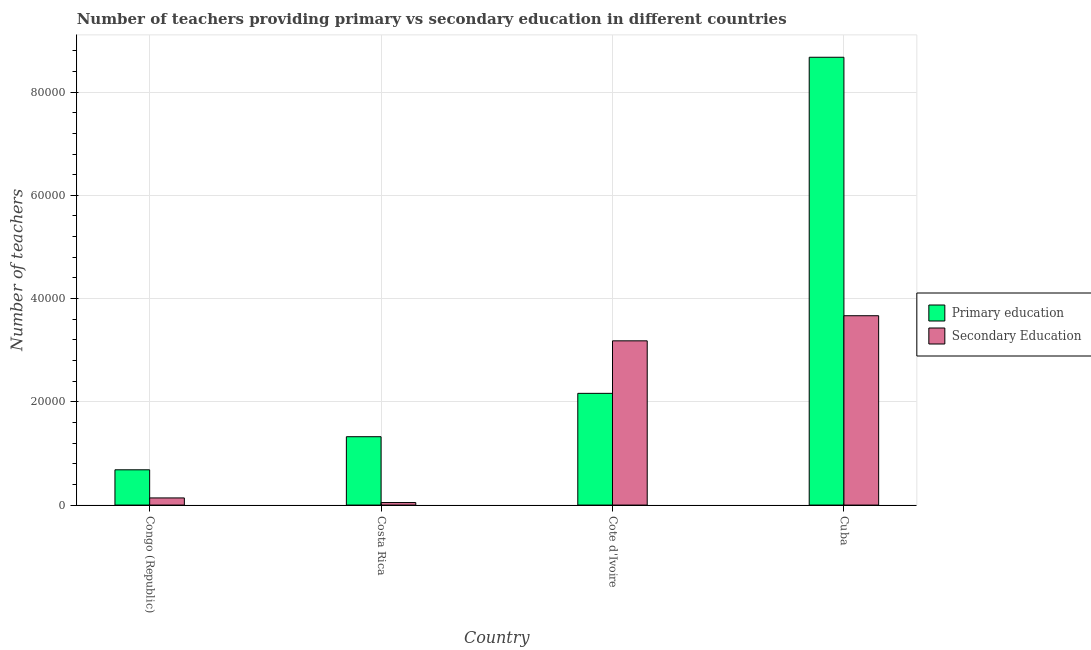How many groups of bars are there?
Ensure brevity in your answer.  4. Are the number of bars on each tick of the X-axis equal?
Provide a short and direct response. Yes. How many bars are there on the 3rd tick from the left?
Your answer should be compact. 2. What is the label of the 4th group of bars from the left?
Provide a succinct answer. Cuba. What is the number of secondary teachers in Congo (Republic)?
Your answer should be compact. 1383. Across all countries, what is the maximum number of primary teachers?
Give a very brief answer. 8.67e+04. Across all countries, what is the minimum number of secondary teachers?
Your answer should be compact. 490. In which country was the number of secondary teachers maximum?
Your answer should be compact. Cuba. In which country was the number of primary teachers minimum?
Give a very brief answer. Congo (Republic). What is the total number of secondary teachers in the graph?
Provide a succinct answer. 7.04e+04. What is the difference between the number of primary teachers in Congo (Republic) and that in Cote d'Ivoire?
Ensure brevity in your answer.  -1.48e+04. What is the difference between the number of primary teachers in Congo (Republic) and the number of secondary teachers in Cuba?
Offer a terse response. -2.98e+04. What is the average number of secondary teachers per country?
Offer a terse response. 1.76e+04. What is the difference between the number of secondary teachers and number of primary teachers in Cuba?
Offer a terse response. -5.01e+04. What is the ratio of the number of secondary teachers in Congo (Republic) to that in Cote d'Ivoire?
Ensure brevity in your answer.  0.04. Is the number of primary teachers in Costa Rica less than that in Cuba?
Provide a short and direct response. Yes. What is the difference between the highest and the second highest number of primary teachers?
Your response must be concise. 6.51e+04. What is the difference between the highest and the lowest number of primary teachers?
Provide a short and direct response. 7.99e+04. In how many countries, is the number of primary teachers greater than the average number of primary teachers taken over all countries?
Your response must be concise. 1. What does the 2nd bar from the left in Cuba represents?
Provide a short and direct response. Secondary Education. What does the 2nd bar from the right in Congo (Republic) represents?
Your response must be concise. Primary education. Are all the bars in the graph horizontal?
Your answer should be very brief. No. How many countries are there in the graph?
Make the answer very short. 4. Are the values on the major ticks of Y-axis written in scientific E-notation?
Offer a terse response. No. Does the graph contain grids?
Offer a terse response. Yes. Where does the legend appear in the graph?
Your answer should be compact. Center right. How many legend labels are there?
Offer a terse response. 2. How are the legend labels stacked?
Make the answer very short. Vertical. What is the title of the graph?
Your answer should be very brief. Number of teachers providing primary vs secondary education in different countries. Does "Female population" appear as one of the legend labels in the graph?
Your response must be concise. No. What is the label or title of the Y-axis?
Offer a terse response. Number of teachers. What is the Number of teachers of Primary education in Congo (Republic)?
Offer a very short reply. 6832. What is the Number of teachers in Secondary Education in Congo (Republic)?
Keep it short and to the point. 1383. What is the Number of teachers in Primary education in Costa Rica?
Offer a very short reply. 1.32e+04. What is the Number of teachers in Secondary Education in Costa Rica?
Provide a succinct answer. 490. What is the Number of teachers in Primary education in Cote d'Ivoire?
Provide a succinct answer. 2.16e+04. What is the Number of teachers of Secondary Education in Cote d'Ivoire?
Your answer should be compact. 3.18e+04. What is the Number of teachers in Primary education in Cuba?
Make the answer very short. 8.67e+04. What is the Number of teachers in Secondary Education in Cuba?
Provide a succinct answer. 3.67e+04. Across all countries, what is the maximum Number of teachers in Primary education?
Make the answer very short. 8.67e+04. Across all countries, what is the maximum Number of teachers in Secondary Education?
Your answer should be very brief. 3.67e+04. Across all countries, what is the minimum Number of teachers in Primary education?
Make the answer very short. 6832. Across all countries, what is the minimum Number of teachers in Secondary Education?
Provide a succinct answer. 490. What is the total Number of teachers in Primary education in the graph?
Your answer should be very brief. 1.28e+05. What is the total Number of teachers of Secondary Education in the graph?
Give a very brief answer. 7.04e+04. What is the difference between the Number of teachers of Primary education in Congo (Republic) and that in Costa Rica?
Your response must be concise. -6410. What is the difference between the Number of teachers of Secondary Education in Congo (Republic) and that in Costa Rica?
Provide a short and direct response. 893. What is the difference between the Number of teachers in Primary education in Congo (Republic) and that in Cote d'Ivoire?
Your answer should be compact. -1.48e+04. What is the difference between the Number of teachers of Secondary Education in Congo (Republic) and that in Cote d'Ivoire?
Offer a very short reply. -3.04e+04. What is the difference between the Number of teachers in Primary education in Congo (Republic) and that in Cuba?
Offer a terse response. -7.99e+04. What is the difference between the Number of teachers of Secondary Education in Congo (Republic) and that in Cuba?
Offer a terse response. -3.53e+04. What is the difference between the Number of teachers in Primary education in Costa Rica and that in Cote d'Ivoire?
Provide a succinct answer. -8398. What is the difference between the Number of teachers of Secondary Education in Costa Rica and that in Cote d'Ivoire?
Make the answer very short. -3.13e+04. What is the difference between the Number of teachers in Primary education in Costa Rica and that in Cuba?
Make the answer very short. -7.35e+04. What is the difference between the Number of teachers in Secondary Education in Costa Rica and that in Cuba?
Your answer should be compact. -3.62e+04. What is the difference between the Number of teachers in Primary education in Cote d'Ivoire and that in Cuba?
Offer a terse response. -6.51e+04. What is the difference between the Number of teachers in Secondary Education in Cote d'Ivoire and that in Cuba?
Offer a very short reply. -4863. What is the difference between the Number of teachers in Primary education in Congo (Republic) and the Number of teachers in Secondary Education in Costa Rica?
Give a very brief answer. 6342. What is the difference between the Number of teachers in Primary education in Congo (Republic) and the Number of teachers in Secondary Education in Cote d'Ivoire?
Offer a very short reply. -2.50e+04. What is the difference between the Number of teachers in Primary education in Congo (Republic) and the Number of teachers in Secondary Education in Cuba?
Provide a short and direct response. -2.98e+04. What is the difference between the Number of teachers in Primary education in Costa Rica and the Number of teachers in Secondary Education in Cote d'Ivoire?
Your response must be concise. -1.86e+04. What is the difference between the Number of teachers in Primary education in Costa Rica and the Number of teachers in Secondary Education in Cuba?
Provide a short and direct response. -2.34e+04. What is the difference between the Number of teachers in Primary education in Cote d'Ivoire and the Number of teachers in Secondary Education in Cuba?
Make the answer very short. -1.50e+04. What is the average Number of teachers in Primary education per country?
Give a very brief answer. 3.21e+04. What is the average Number of teachers of Secondary Education per country?
Your response must be concise. 1.76e+04. What is the difference between the Number of teachers in Primary education and Number of teachers in Secondary Education in Congo (Republic)?
Provide a succinct answer. 5449. What is the difference between the Number of teachers in Primary education and Number of teachers in Secondary Education in Costa Rica?
Make the answer very short. 1.28e+04. What is the difference between the Number of teachers in Primary education and Number of teachers in Secondary Education in Cote d'Ivoire?
Give a very brief answer. -1.02e+04. What is the difference between the Number of teachers in Primary education and Number of teachers in Secondary Education in Cuba?
Make the answer very short. 5.01e+04. What is the ratio of the Number of teachers in Primary education in Congo (Republic) to that in Costa Rica?
Provide a succinct answer. 0.52. What is the ratio of the Number of teachers in Secondary Education in Congo (Republic) to that in Costa Rica?
Keep it short and to the point. 2.82. What is the ratio of the Number of teachers of Primary education in Congo (Republic) to that in Cote d'Ivoire?
Keep it short and to the point. 0.32. What is the ratio of the Number of teachers of Secondary Education in Congo (Republic) to that in Cote d'Ivoire?
Provide a succinct answer. 0.04. What is the ratio of the Number of teachers in Primary education in Congo (Republic) to that in Cuba?
Your answer should be compact. 0.08. What is the ratio of the Number of teachers of Secondary Education in Congo (Republic) to that in Cuba?
Offer a very short reply. 0.04. What is the ratio of the Number of teachers in Primary education in Costa Rica to that in Cote d'Ivoire?
Your response must be concise. 0.61. What is the ratio of the Number of teachers of Secondary Education in Costa Rica to that in Cote d'Ivoire?
Give a very brief answer. 0.02. What is the ratio of the Number of teachers of Primary education in Costa Rica to that in Cuba?
Your response must be concise. 0.15. What is the ratio of the Number of teachers in Secondary Education in Costa Rica to that in Cuba?
Your response must be concise. 0.01. What is the ratio of the Number of teachers of Primary education in Cote d'Ivoire to that in Cuba?
Your answer should be compact. 0.25. What is the ratio of the Number of teachers in Secondary Education in Cote d'Ivoire to that in Cuba?
Offer a terse response. 0.87. What is the difference between the highest and the second highest Number of teachers in Primary education?
Offer a terse response. 6.51e+04. What is the difference between the highest and the second highest Number of teachers in Secondary Education?
Provide a succinct answer. 4863. What is the difference between the highest and the lowest Number of teachers of Primary education?
Ensure brevity in your answer.  7.99e+04. What is the difference between the highest and the lowest Number of teachers in Secondary Education?
Provide a succinct answer. 3.62e+04. 